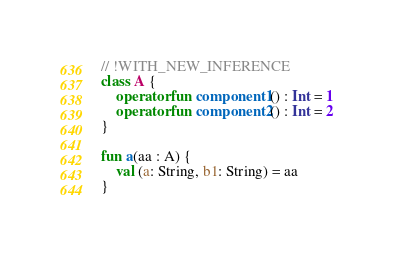Convert code to text. <code><loc_0><loc_0><loc_500><loc_500><_Kotlin_>// !WITH_NEW_INFERENCE
class A {
    operator fun component1() : Int = 1
    operator fun component2() : Int = 2
}

fun a(aa : A) {
    val (a: String, b1: String) = aa
}
</code> 